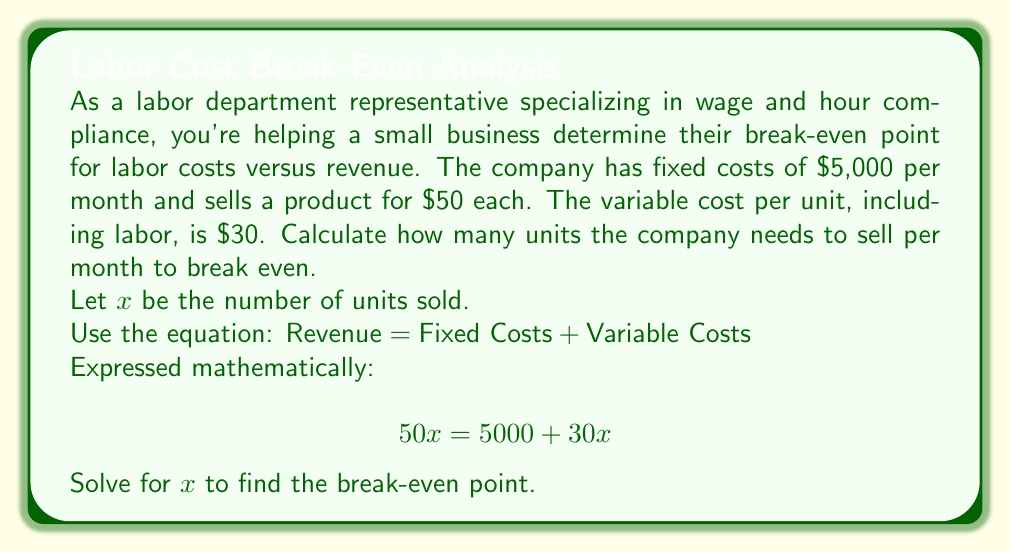Help me with this question. To solve this problem, we'll follow these steps:

1) Start with the break-even equation:
   $$50x = 5000 + 30x$$

2) Subtract $30x$ from both sides:
   $$50x - 30x = 5000 + 30x - 30x$$
   $$20x = 5000$$

3) Divide both sides by 20:
   $$\frac{20x}{20} = \frac{5000}{20}$$
   $$x = 250$$

The break-even point is 250 units.

To verify:
- Revenue: $50 * 250 = $12,500
- Fixed Costs: $5,000
- Variable Costs: $30 * 250 = $7,500
- Total Costs: $5,000 + $7,500 = $12,500

Revenue equals Total Costs, confirming the break-even point.
Answer: The company needs to sell 250 units per month to break even. 